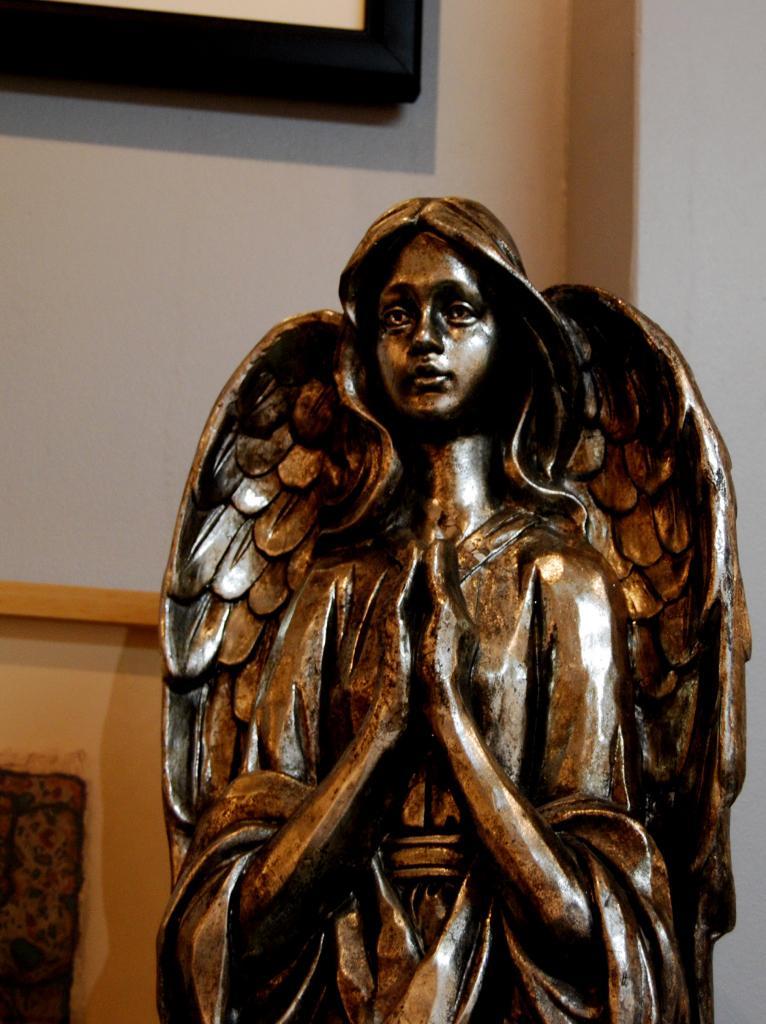Describe this image in one or two sentences. In this image we can see the depiction of a woman with the wings. In the background we can see the wall and also a frame. 